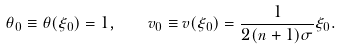Convert formula to latex. <formula><loc_0><loc_0><loc_500><loc_500>\theta _ { 0 } \equiv \theta ( \xi _ { 0 } ) = 1 , \quad v _ { 0 } \equiv v ( \xi _ { 0 } ) = \frac { 1 } { 2 ( n + 1 ) \sigma } \xi _ { 0 } .</formula> 